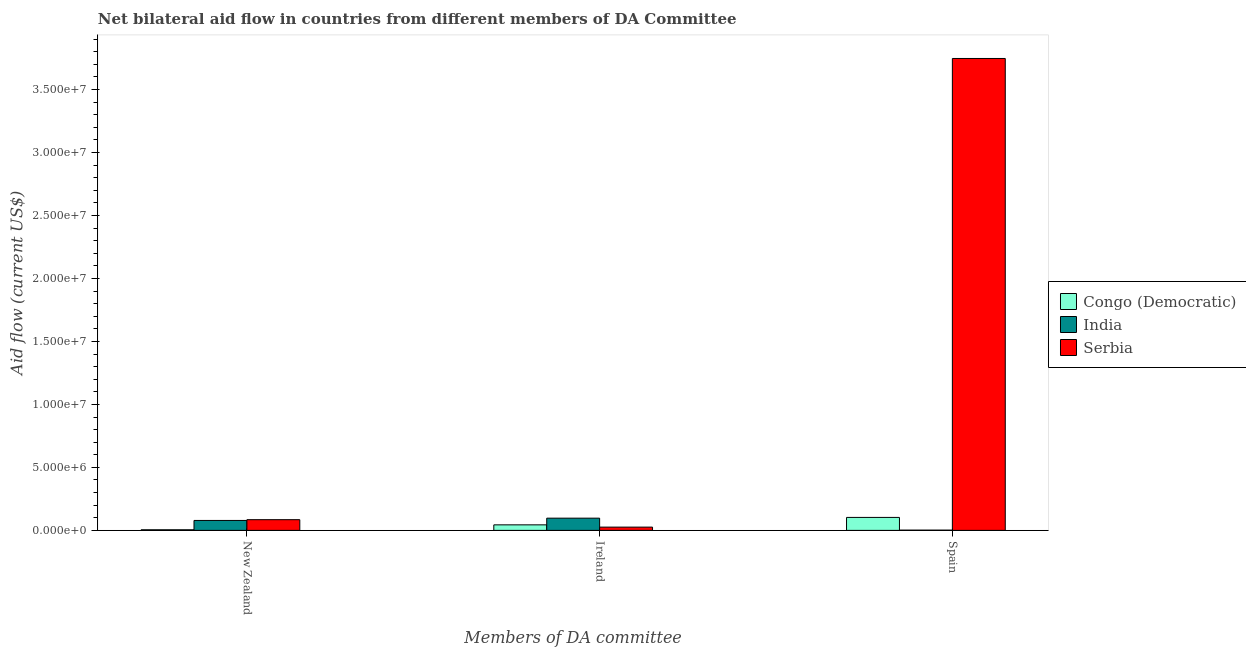How many groups of bars are there?
Make the answer very short. 3. Are the number of bars per tick equal to the number of legend labels?
Your answer should be very brief. Yes. Are the number of bars on each tick of the X-axis equal?
Ensure brevity in your answer.  Yes. How many bars are there on the 3rd tick from the left?
Your response must be concise. 3. What is the amount of aid provided by ireland in Congo (Democratic)?
Make the answer very short. 4.40e+05. Across all countries, what is the maximum amount of aid provided by new zealand?
Make the answer very short. 8.50e+05. Across all countries, what is the minimum amount of aid provided by ireland?
Provide a succinct answer. 2.60e+05. In which country was the amount of aid provided by new zealand maximum?
Provide a succinct answer. Serbia. In which country was the amount of aid provided by new zealand minimum?
Make the answer very short. Congo (Democratic). What is the total amount of aid provided by new zealand in the graph?
Make the answer very short. 1.69e+06. What is the difference between the amount of aid provided by ireland in Congo (Democratic) and that in Serbia?
Make the answer very short. 1.80e+05. What is the difference between the amount of aid provided by spain in Congo (Democratic) and the amount of aid provided by ireland in Serbia?
Give a very brief answer. 7.70e+05. What is the average amount of aid provided by spain per country?
Ensure brevity in your answer.  1.28e+07. What is the difference between the amount of aid provided by spain and amount of aid provided by ireland in India?
Ensure brevity in your answer.  -9.50e+05. What is the ratio of the amount of aid provided by spain in Serbia to that in Congo (Democratic)?
Make the answer very short. 36.37. Is the amount of aid provided by spain in Serbia less than that in Congo (Democratic)?
Keep it short and to the point. No. Is the difference between the amount of aid provided by new zealand in Congo (Democratic) and India greater than the difference between the amount of aid provided by spain in Congo (Democratic) and India?
Keep it short and to the point. No. What is the difference between the highest and the second highest amount of aid provided by new zealand?
Provide a short and direct response. 6.00e+04. What is the difference between the highest and the lowest amount of aid provided by new zealand?
Keep it short and to the point. 8.00e+05. In how many countries, is the amount of aid provided by new zealand greater than the average amount of aid provided by new zealand taken over all countries?
Make the answer very short. 2. What does the 3rd bar from the left in New Zealand represents?
Your answer should be compact. Serbia. What does the 3rd bar from the right in Ireland represents?
Offer a very short reply. Congo (Democratic). Is it the case that in every country, the sum of the amount of aid provided by new zealand and amount of aid provided by ireland is greater than the amount of aid provided by spain?
Offer a terse response. No. What is the difference between two consecutive major ticks on the Y-axis?
Offer a terse response. 5.00e+06. Are the values on the major ticks of Y-axis written in scientific E-notation?
Ensure brevity in your answer.  Yes. How are the legend labels stacked?
Offer a very short reply. Vertical. What is the title of the graph?
Give a very brief answer. Net bilateral aid flow in countries from different members of DA Committee. What is the label or title of the X-axis?
Your answer should be very brief. Members of DA committee. What is the label or title of the Y-axis?
Keep it short and to the point. Aid flow (current US$). What is the Aid flow (current US$) of Congo (Democratic) in New Zealand?
Ensure brevity in your answer.  5.00e+04. What is the Aid flow (current US$) of India in New Zealand?
Offer a very short reply. 7.90e+05. What is the Aid flow (current US$) in Serbia in New Zealand?
Provide a succinct answer. 8.50e+05. What is the Aid flow (current US$) in Congo (Democratic) in Ireland?
Provide a short and direct response. 4.40e+05. What is the Aid flow (current US$) of India in Ireland?
Provide a short and direct response. 9.70e+05. What is the Aid flow (current US$) of Congo (Democratic) in Spain?
Give a very brief answer. 1.03e+06. What is the Aid flow (current US$) in India in Spain?
Ensure brevity in your answer.  2.00e+04. What is the Aid flow (current US$) of Serbia in Spain?
Ensure brevity in your answer.  3.75e+07. Across all Members of DA committee, what is the maximum Aid flow (current US$) of Congo (Democratic)?
Your answer should be compact. 1.03e+06. Across all Members of DA committee, what is the maximum Aid flow (current US$) of India?
Offer a terse response. 9.70e+05. Across all Members of DA committee, what is the maximum Aid flow (current US$) in Serbia?
Give a very brief answer. 3.75e+07. Across all Members of DA committee, what is the minimum Aid flow (current US$) of Congo (Democratic)?
Provide a succinct answer. 5.00e+04. Across all Members of DA committee, what is the minimum Aid flow (current US$) of Serbia?
Make the answer very short. 2.60e+05. What is the total Aid flow (current US$) of Congo (Democratic) in the graph?
Offer a terse response. 1.52e+06. What is the total Aid flow (current US$) of India in the graph?
Offer a terse response. 1.78e+06. What is the total Aid flow (current US$) of Serbia in the graph?
Your answer should be compact. 3.86e+07. What is the difference between the Aid flow (current US$) of Congo (Democratic) in New Zealand and that in Ireland?
Your answer should be very brief. -3.90e+05. What is the difference between the Aid flow (current US$) of Serbia in New Zealand and that in Ireland?
Give a very brief answer. 5.90e+05. What is the difference between the Aid flow (current US$) in Congo (Democratic) in New Zealand and that in Spain?
Offer a terse response. -9.80e+05. What is the difference between the Aid flow (current US$) of India in New Zealand and that in Spain?
Keep it short and to the point. 7.70e+05. What is the difference between the Aid flow (current US$) in Serbia in New Zealand and that in Spain?
Keep it short and to the point. -3.66e+07. What is the difference between the Aid flow (current US$) of Congo (Democratic) in Ireland and that in Spain?
Provide a short and direct response. -5.90e+05. What is the difference between the Aid flow (current US$) of India in Ireland and that in Spain?
Make the answer very short. 9.50e+05. What is the difference between the Aid flow (current US$) of Serbia in Ireland and that in Spain?
Ensure brevity in your answer.  -3.72e+07. What is the difference between the Aid flow (current US$) in Congo (Democratic) in New Zealand and the Aid flow (current US$) in India in Ireland?
Keep it short and to the point. -9.20e+05. What is the difference between the Aid flow (current US$) in Congo (Democratic) in New Zealand and the Aid flow (current US$) in Serbia in Ireland?
Your answer should be compact. -2.10e+05. What is the difference between the Aid flow (current US$) of India in New Zealand and the Aid flow (current US$) of Serbia in Ireland?
Keep it short and to the point. 5.30e+05. What is the difference between the Aid flow (current US$) of Congo (Democratic) in New Zealand and the Aid flow (current US$) of Serbia in Spain?
Make the answer very short. -3.74e+07. What is the difference between the Aid flow (current US$) of India in New Zealand and the Aid flow (current US$) of Serbia in Spain?
Keep it short and to the point. -3.67e+07. What is the difference between the Aid flow (current US$) of Congo (Democratic) in Ireland and the Aid flow (current US$) of Serbia in Spain?
Your response must be concise. -3.70e+07. What is the difference between the Aid flow (current US$) of India in Ireland and the Aid flow (current US$) of Serbia in Spain?
Make the answer very short. -3.65e+07. What is the average Aid flow (current US$) in Congo (Democratic) per Members of DA committee?
Your response must be concise. 5.07e+05. What is the average Aid flow (current US$) in India per Members of DA committee?
Your response must be concise. 5.93e+05. What is the average Aid flow (current US$) in Serbia per Members of DA committee?
Offer a terse response. 1.29e+07. What is the difference between the Aid flow (current US$) of Congo (Democratic) and Aid flow (current US$) of India in New Zealand?
Your response must be concise. -7.40e+05. What is the difference between the Aid flow (current US$) of Congo (Democratic) and Aid flow (current US$) of Serbia in New Zealand?
Your response must be concise. -8.00e+05. What is the difference between the Aid flow (current US$) in Congo (Democratic) and Aid flow (current US$) in India in Ireland?
Make the answer very short. -5.30e+05. What is the difference between the Aid flow (current US$) of India and Aid flow (current US$) of Serbia in Ireland?
Make the answer very short. 7.10e+05. What is the difference between the Aid flow (current US$) of Congo (Democratic) and Aid flow (current US$) of India in Spain?
Provide a succinct answer. 1.01e+06. What is the difference between the Aid flow (current US$) of Congo (Democratic) and Aid flow (current US$) of Serbia in Spain?
Provide a short and direct response. -3.64e+07. What is the difference between the Aid flow (current US$) in India and Aid flow (current US$) in Serbia in Spain?
Keep it short and to the point. -3.74e+07. What is the ratio of the Aid flow (current US$) in Congo (Democratic) in New Zealand to that in Ireland?
Your answer should be very brief. 0.11. What is the ratio of the Aid flow (current US$) of India in New Zealand to that in Ireland?
Keep it short and to the point. 0.81. What is the ratio of the Aid flow (current US$) in Serbia in New Zealand to that in Ireland?
Your answer should be compact. 3.27. What is the ratio of the Aid flow (current US$) in Congo (Democratic) in New Zealand to that in Spain?
Your response must be concise. 0.05. What is the ratio of the Aid flow (current US$) in India in New Zealand to that in Spain?
Your response must be concise. 39.5. What is the ratio of the Aid flow (current US$) of Serbia in New Zealand to that in Spain?
Offer a very short reply. 0.02. What is the ratio of the Aid flow (current US$) of Congo (Democratic) in Ireland to that in Spain?
Provide a succinct answer. 0.43. What is the ratio of the Aid flow (current US$) of India in Ireland to that in Spain?
Make the answer very short. 48.5. What is the ratio of the Aid flow (current US$) of Serbia in Ireland to that in Spain?
Ensure brevity in your answer.  0.01. What is the difference between the highest and the second highest Aid flow (current US$) in Congo (Democratic)?
Provide a succinct answer. 5.90e+05. What is the difference between the highest and the second highest Aid flow (current US$) of India?
Give a very brief answer. 1.80e+05. What is the difference between the highest and the second highest Aid flow (current US$) of Serbia?
Ensure brevity in your answer.  3.66e+07. What is the difference between the highest and the lowest Aid flow (current US$) in Congo (Democratic)?
Your response must be concise. 9.80e+05. What is the difference between the highest and the lowest Aid flow (current US$) of India?
Keep it short and to the point. 9.50e+05. What is the difference between the highest and the lowest Aid flow (current US$) in Serbia?
Offer a terse response. 3.72e+07. 